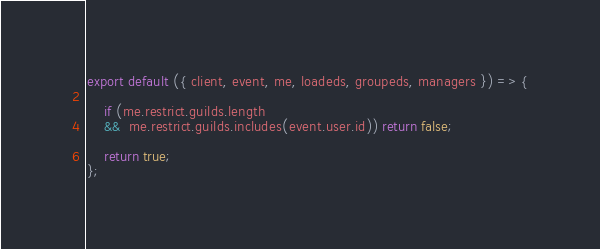Convert code to text. <code><loc_0><loc_0><loc_500><loc_500><_JavaScript_>export default ({ client, event, me, loadeds, groupeds, managers }) => {

    if (me.restrict.guilds.length
    &&  me.restrict.guilds.includes(event.user.id)) return false;

    return true;
};</code> 